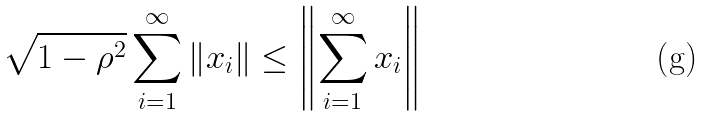Convert formula to latex. <formula><loc_0><loc_0><loc_500><loc_500>\sqrt { 1 - \rho ^ { 2 } } \sum _ { i = 1 } ^ { \infty } \left \| x _ { i } \right \| \leq \left \| \sum _ { i = 1 } ^ { \infty } x _ { i } \right \|</formula> 